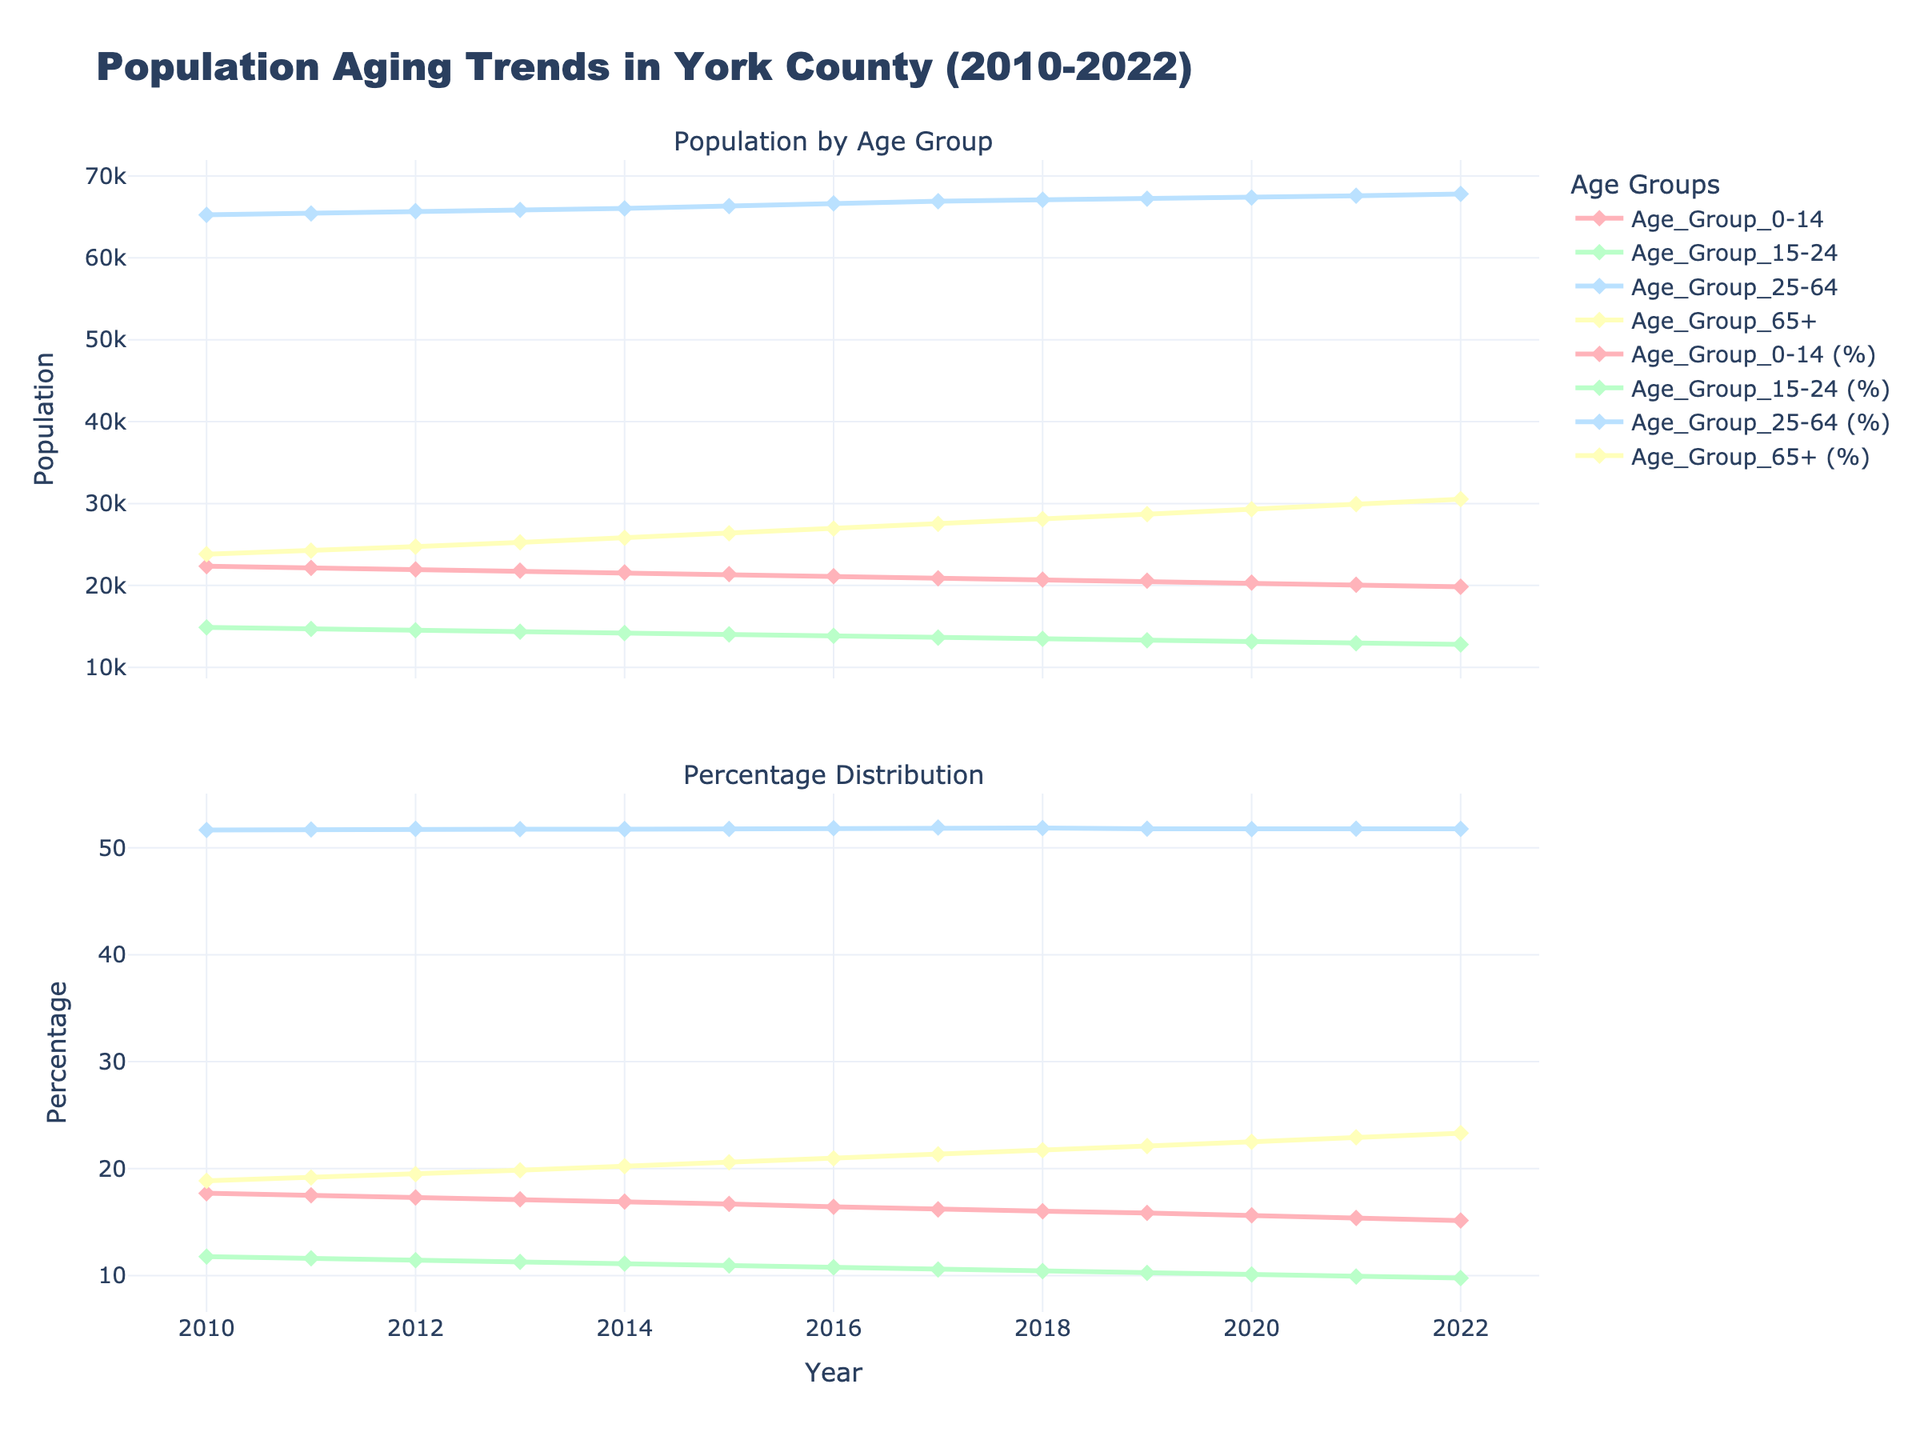What are the two main sections of the figure? The figure is divided into two parts. The first part is "Population by Age Group," which shows the actual number of people in each age group over the years. The second part is "Percentage Distribution," which displays the percentage of each age group relative to the total population over the years.
Answer: "Population by Age Group" and "Percentage Distribution" What is the color used for the age group "Age_Group_0-14"? The color for the age group "Age_Group_0-14" can be identified by looking at its line in the legend and corresponding plot. It is represented by a light pink color.
Answer: Light pink How does the population of the 65+ age group change from 2010 to 2022? To determine the change, look at the values for the 65+ age group in 2010 (23,820) and in 2022 (30,540). Subtract the 2010 value from the 2022 value.
Answer: Increased by 6,720 In which year did the 0-14 age group have its highest population? By observing the data points in the "Population by Age Group" section for the "Age_Group_0-14" series, the highest point occurs in 2010.
Answer: 2010 How did the percentage of the 25-64 age group change from 2010 to 2022? To solve this, look at the percentage distribution for the 25-64 age group in 2010 and 2022. Use the data points to figure out that it decreased slightly over the period.
Answer: Slightly decreased What is the overall trend for the 0-14 age group from 2010 to 2022? Observing the "Population by Age Group" plot reveals a consistent decrease in the population of the 0-14 age group from 2010 to 2022.
Answer: Consistent decrease Which age group had the smallest population in 2022? Look at the "Population by Age Group" section for the year 2022 to compare all groups. The "Age_Group_15-24" has the smallest value at 12,790.
Answer: Age_Group_15-24 During which year did the 65+ age group reach 25,000 for the first time? Track the data points in the "Population by Age Group" section for the 65+ series and identify the first year it crosses 25,000, which is 2013 (25,260).
Answer: 2013 What can you infer from the percentage distribution of age groups between 0-14 and 65+ over the period? By observing the "Percentage Distribution" plot, it is evident that the percentage of the 0-14 group decreased, while the 65+ group increased steadily from 2010 to 2022, showing aging trends.
Answer: 0-14 decreased, 65+ increased 